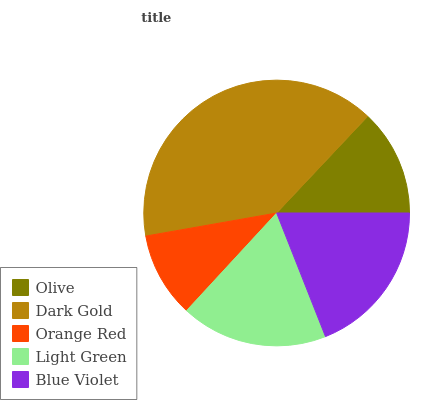Is Orange Red the minimum?
Answer yes or no. Yes. Is Dark Gold the maximum?
Answer yes or no. Yes. Is Dark Gold the minimum?
Answer yes or no. No. Is Orange Red the maximum?
Answer yes or no. No. Is Dark Gold greater than Orange Red?
Answer yes or no. Yes. Is Orange Red less than Dark Gold?
Answer yes or no. Yes. Is Orange Red greater than Dark Gold?
Answer yes or no. No. Is Dark Gold less than Orange Red?
Answer yes or no. No. Is Light Green the high median?
Answer yes or no. Yes. Is Light Green the low median?
Answer yes or no. Yes. Is Blue Violet the high median?
Answer yes or no. No. Is Blue Violet the low median?
Answer yes or no. No. 